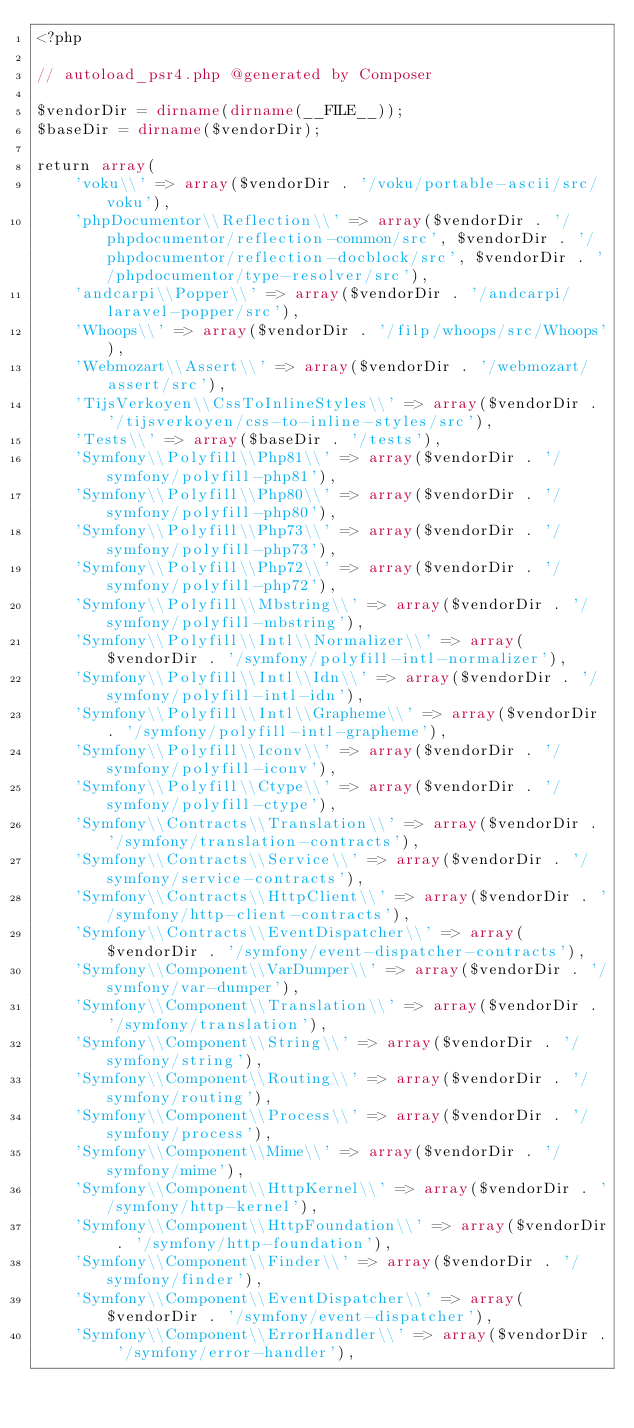<code> <loc_0><loc_0><loc_500><loc_500><_PHP_><?php

// autoload_psr4.php @generated by Composer

$vendorDir = dirname(dirname(__FILE__));
$baseDir = dirname($vendorDir);

return array(
    'voku\\' => array($vendorDir . '/voku/portable-ascii/src/voku'),
    'phpDocumentor\\Reflection\\' => array($vendorDir . '/phpdocumentor/reflection-common/src', $vendorDir . '/phpdocumentor/reflection-docblock/src', $vendorDir . '/phpdocumentor/type-resolver/src'),
    'andcarpi\\Popper\\' => array($vendorDir . '/andcarpi/laravel-popper/src'),
    'Whoops\\' => array($vendorDir . '/filp/whoops/src/Whoops'),
    'Webmozart\\Assert\\' => array($vendorDir . '/webmozart/assert/src'),
    'TijsVerkoyen\\CssToInlineStyles\\' => array($vendorDir . '/tijsverkoyen/css-to-inline-styles/src'),
    'Tests\\' => array($baseDir . '/tests'),
    'Symfony\\Polyfill\\Php81\\' => array($vendorDir . '/symfony/polyfill-php81'),
    'Symfony\\Polyfill\\Php80\\' => array($vendorDir . '/symfony/polyfill-php80'),
    'Symfony\\Polyfill\\Php73\\' => array($vendorDir . '/symfony/polyfill-php73'),
    'Symfony\\Polyfill\\Php72\\' => array($vendorDir . '/symfony/polyfill-php72'),
    'Symfony\\Polyfill\\Mbstring\\' => array($vendorDir . '/symfony/polyfill-mbstring'),
    'Symfony\\Polyfill\\Intl\\Normalizer\\' => array($vendorDir . '/symfony/polyfill-intl-normalizer'),
    'Symfony\\Polyfill\\Intl\\Idn\\' => array($vendorDir . '/symfony/polyfill-intl-idn'),
    'Symfony\\Polyfill\\Intl\\Grapheme\\' => array($vendorDir . '/symfony/polyfill-intl-grapheme'),
    'Symfony\\Polyfill\\Iconv\\' => array($vendorDir . '/symfony/polyfill-iconv'),
    'Symfony\\Polyfill\\Ctype\\' => array($vendorDir . '/symfony/polyfill-ctype'),
    'Symfony\\Contracts\\Translation\\' => array($vendorDir . '/symfony/translation-contracts'),
    'Symfony\\Contracts\\Service\\' => array($vendorDir . '/symfony/service-contracts'),
    'Symfony\\Contracts\\HttpClient\\' => array($vendorDir . '/symfony/http-client-contracts'),
    'Symfony\\Contracts\\EventDispatcher\\' => array($vendorDir . '/symfony/event-dispatcher-contracts'),
    'Symfony\\Component\\VarDumper\\' => array($vendorDir . '/symfony/var-dumper'),
    'Symfony\\Component\\Translation\\' => array($vendorDir . '/symfony/translation'),
    'Symfony\\Component\\String\\' => array($vendorDir . '/symfony/string'),
    'Symfony\\Component\\Routing\\' => array($vendorDir . '/symfony/routing'),
    'Symfony\\Component\\Process\\' => array($vendorDir . '/symfony/process'),
    'Symfony\\Component\\Mime\\' => array($vendorDir . '/symfony/mime'),
    'Symfony\\Component\\HttpKernel\\' => array($vendorDir . '/symfony/http-kernel'),
    'Symfony\\Component\\HttpFoundation\\' => array($vendorDir . '/symfony/http-foundation'),
    'Symfony\\Component\\Finder\\' => array($vendorDir . '/symfony/finder'),
    'Symfony\\Component\\EventDispatcher\\' => array($vendorDir . '/symfony/event-dispatcher'),
    'Symfony\\Component\\ErrorHandler\\' => array($vendorDir . '/symfony/error-handler'),</code> 